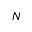<formula> <loc_0><loc_0><loc_500><loc_500>_ { N }</formula> 